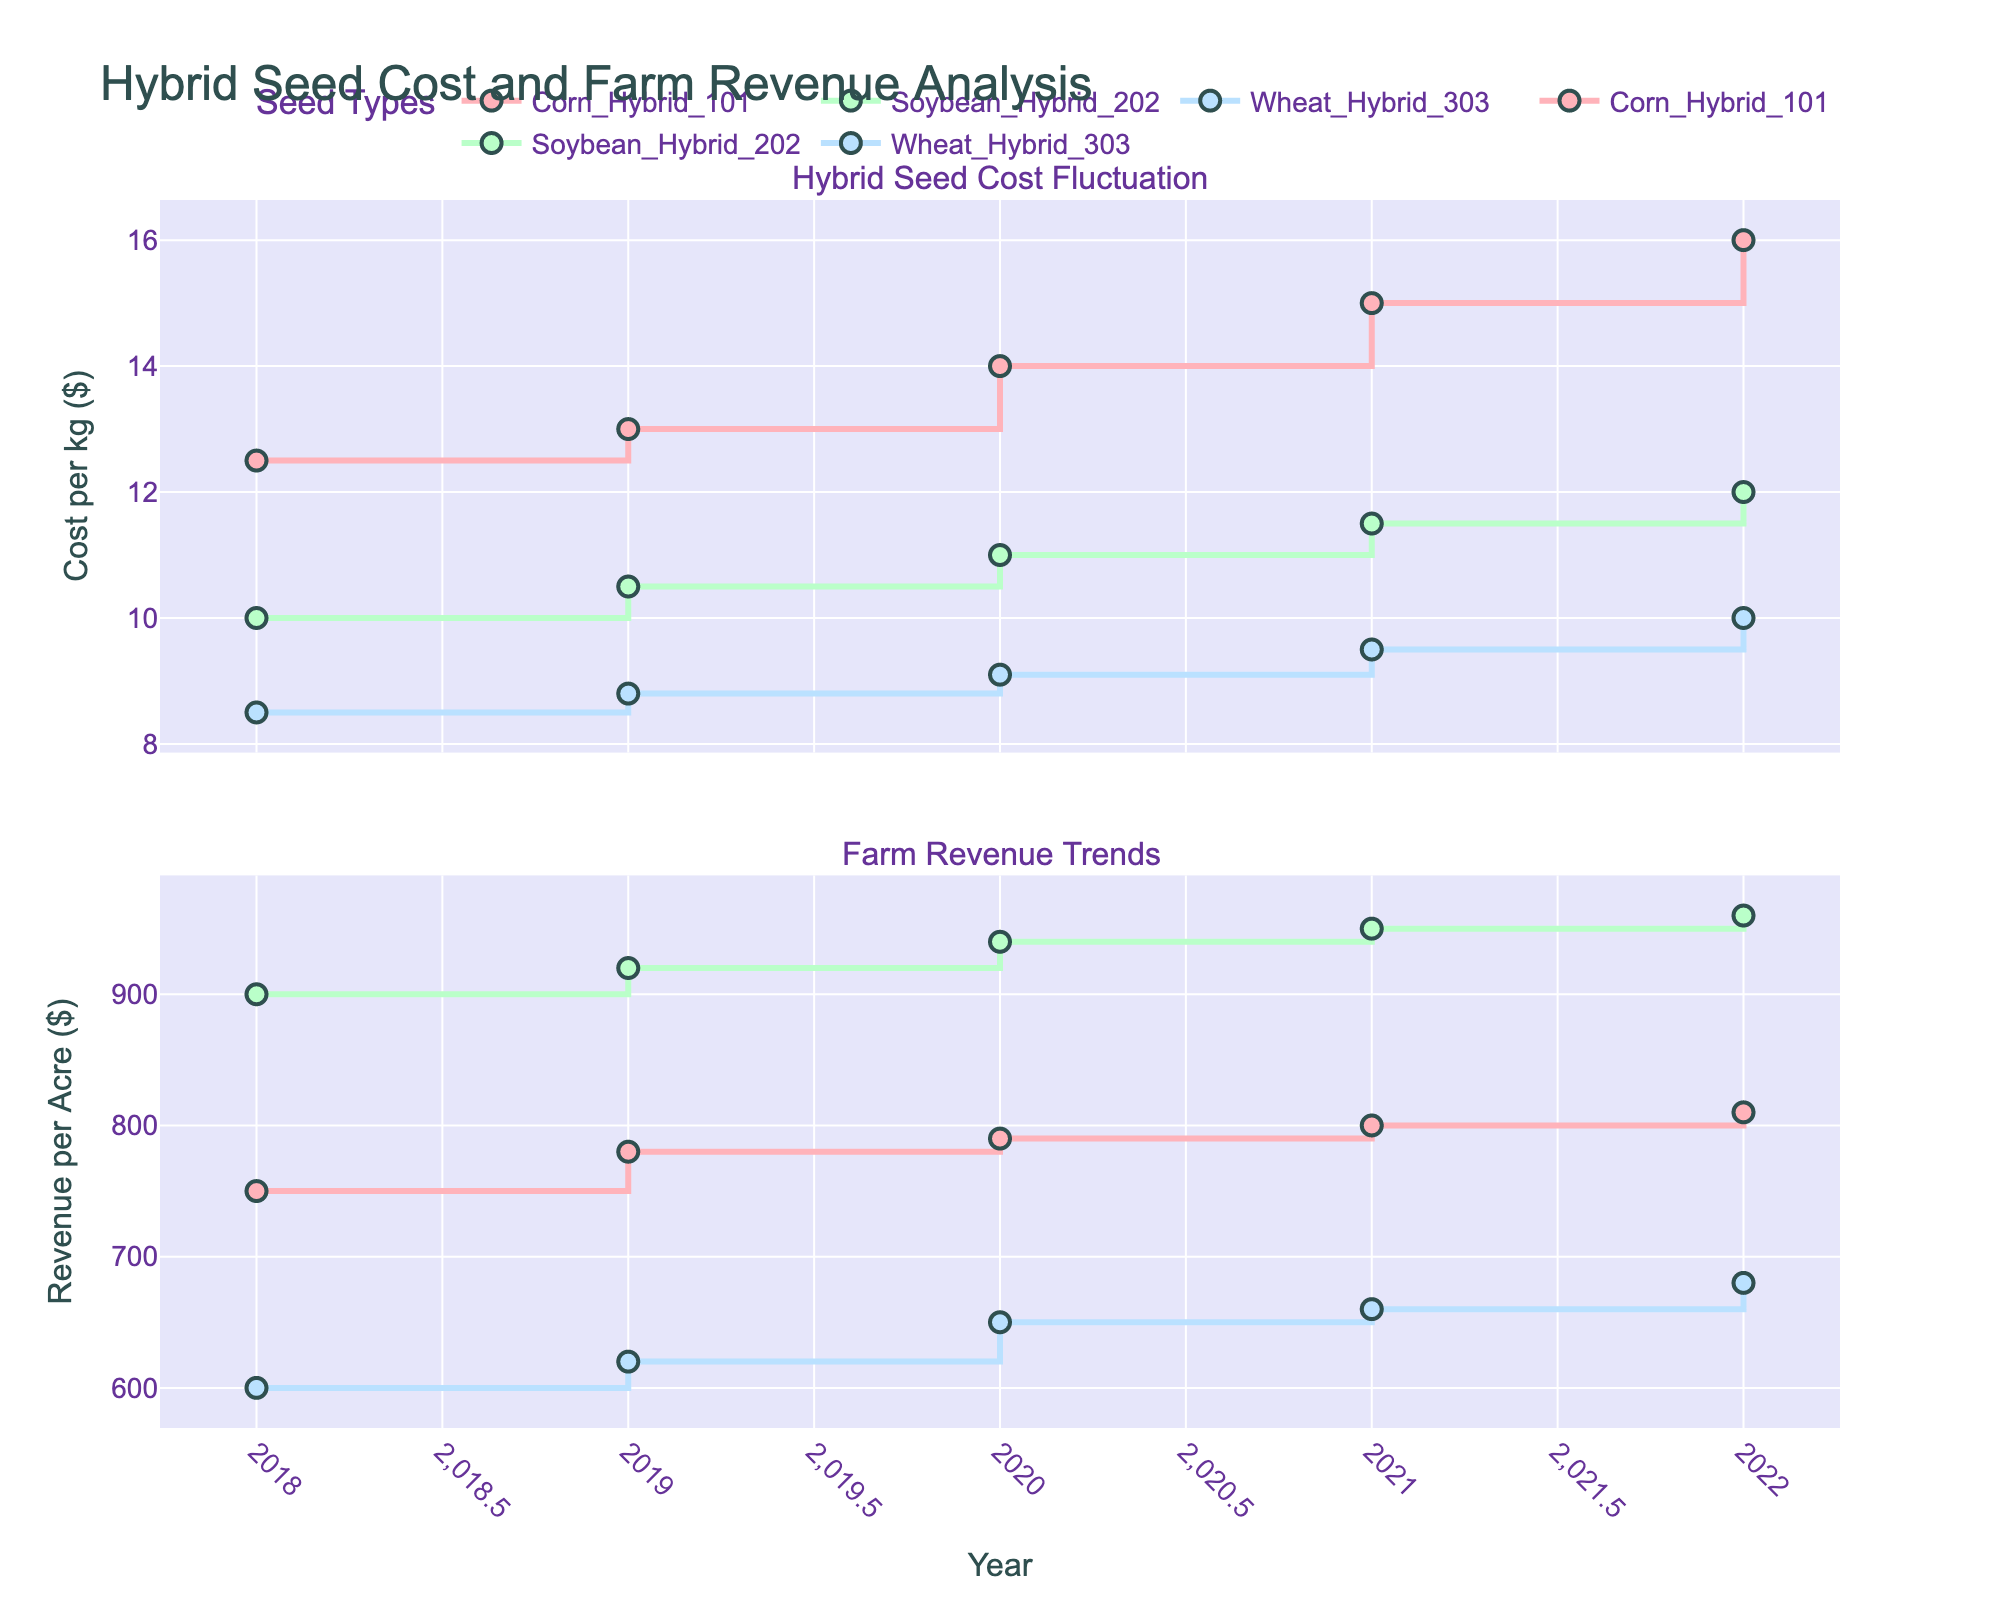What is the title of the figure? The title of the figure is displayed prominently at the top and titled "Hybrid Seed Cost and Farm Revenue Analysis".
Answer: Hybrid Seed Cost and Farm Revenue Analysis What is the trend in the cost per kg of Corn Hybrid 101 from 2018 to 2022? From inspecting the visual pattern of the red line in the upper plot, the cost per kg of Corn Hybrid 101 increases steadily from 2018 to 2022.
Answer: It increases Which seed type had the highest revenue per acre in 2022? The green line in the lower plot shows that Soybean Hybrid 202 had the highest revenue per acre in 2022.
Answer: Soybean Hybrid 202 How did the revenue per acre of Wheat Hybrid 303 change from 2018 to 2020? By inspecting the blue line in the lower plot from 2018 to 2020, we see a steady increase in revenue per acre from 600 to 650.
Answer: It increased Compare the cost per kg of Soybean Hybrid 202 to Wheat Hybrid 303 in 2021. Which one is higher and by how much? In 2021, the cost per kg of Soybean Hybrid 202 (green line) was $11.5. The cost per kg of Wheat Hybrid 303 (blue line) was $9.5. The difference is $11.5 - $9.5 = $2.
Answer: Soybean Hybrid 202 is higher by $2 Which seed type shows the most significant increase in revenue per acre over the years 2018 to 2022? By looking at the lower plot and comparing the slopes of the lines, Soybean Hybrid 202's revenue per acre (green line) shows the most significant increase from 900 in 2018 to 960 in 2022.
Answer: Soybean Hybrid 202 What year did Corn Hybrid 101 see its largest annual increase in cost per kg? By observing the step changes in the red line in the upper plot, the most significant increase happened between 2020 and 2021 ($14.0 to $15.0).
Answer: 2021 Which year saw the smallest difference between the cost per kg of Corn Hybrid 101 and Soybean Hybrid 202? By comparing the red and green lines in the upper plot for each year, 2019 saw the smallest difference, with Corn Hybrid 101 at $13.0 and Soybean Hybrid 202 at $10.5, a $2.5 difference.
Answer: 2019 